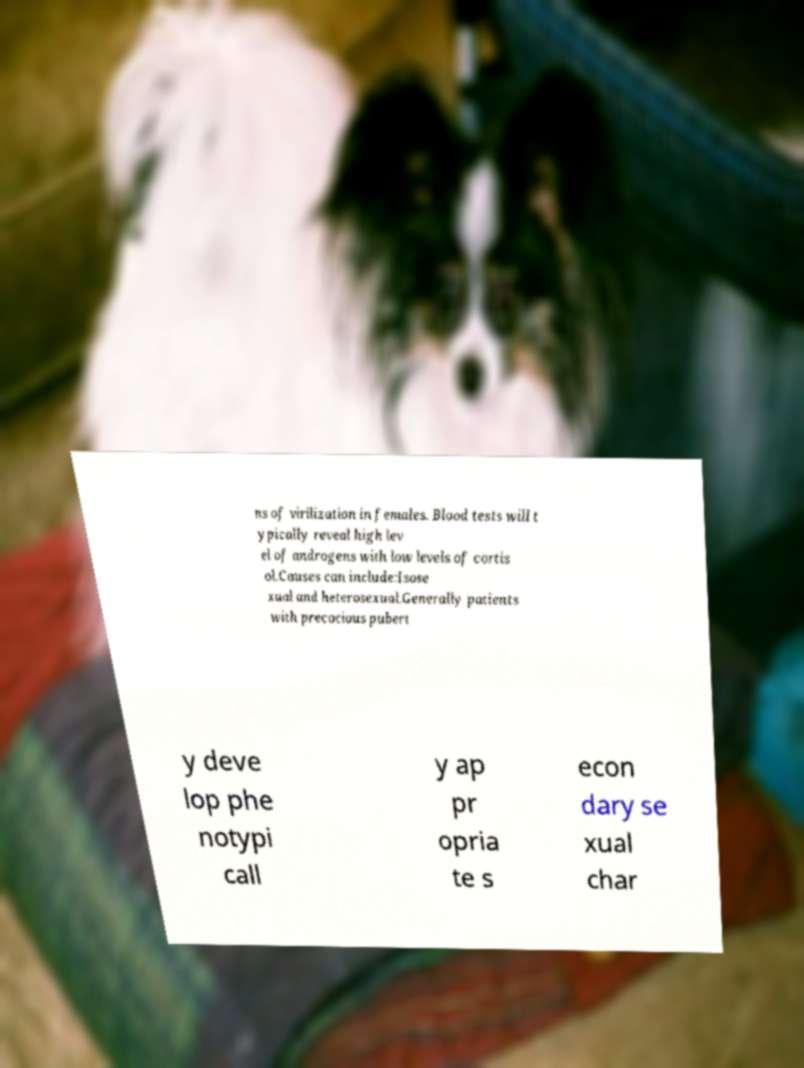Could you extract and type out the text from this image? ns of virilization in females. Blood tests will t ypically reveal high lev el of androgens with low levels of cortis ol.Causes can include:Isose xual and heterosexual.Generally patients with precocious pubert y deve lop phe notypi call y ap pr opria te s econ dary se xual char 